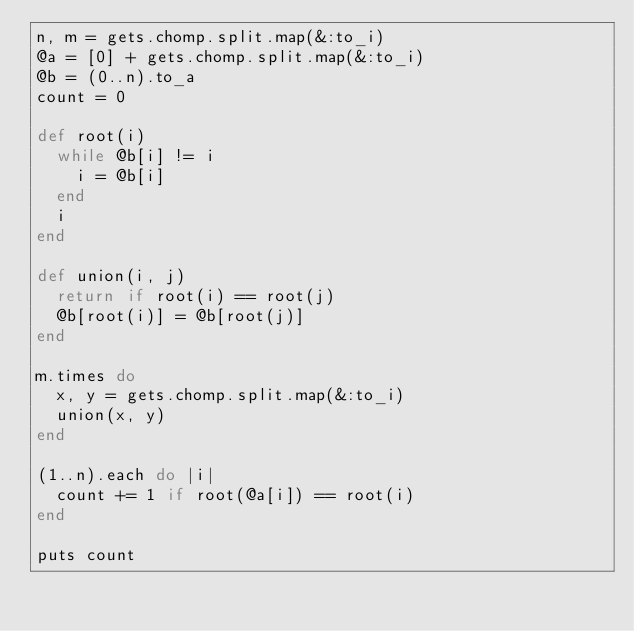<code> <loc_0><loc_0><loc_500><loc_500><_Ruby_>n, m = gets.chomp.split.map(&:to_i)
@a = [0] + gets.chomp.split.map(&:to_i)
@b = (0..n).to_a
count = 0

def root(i)
  while @b[i] != i
    i = @b[i]
  end
  i
end

def union(i, j)
  return if root(i) == root(j)
  @b[root(i)] = @b[root(j)]
end

m.times do
  x, y = gets.chomp.split.map(&:to_i)
  union(x, y)
end

(1..n).each do |i|
  count += 1 if root(@a[i]) == root(i)  
end

puts count</code> 